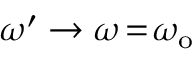<formula> <loc_0><loc_0><loc_500><loc_500>\omega ^ { \prime } \rightarrow \omega \, = \, \omega _ { o }</formula> 